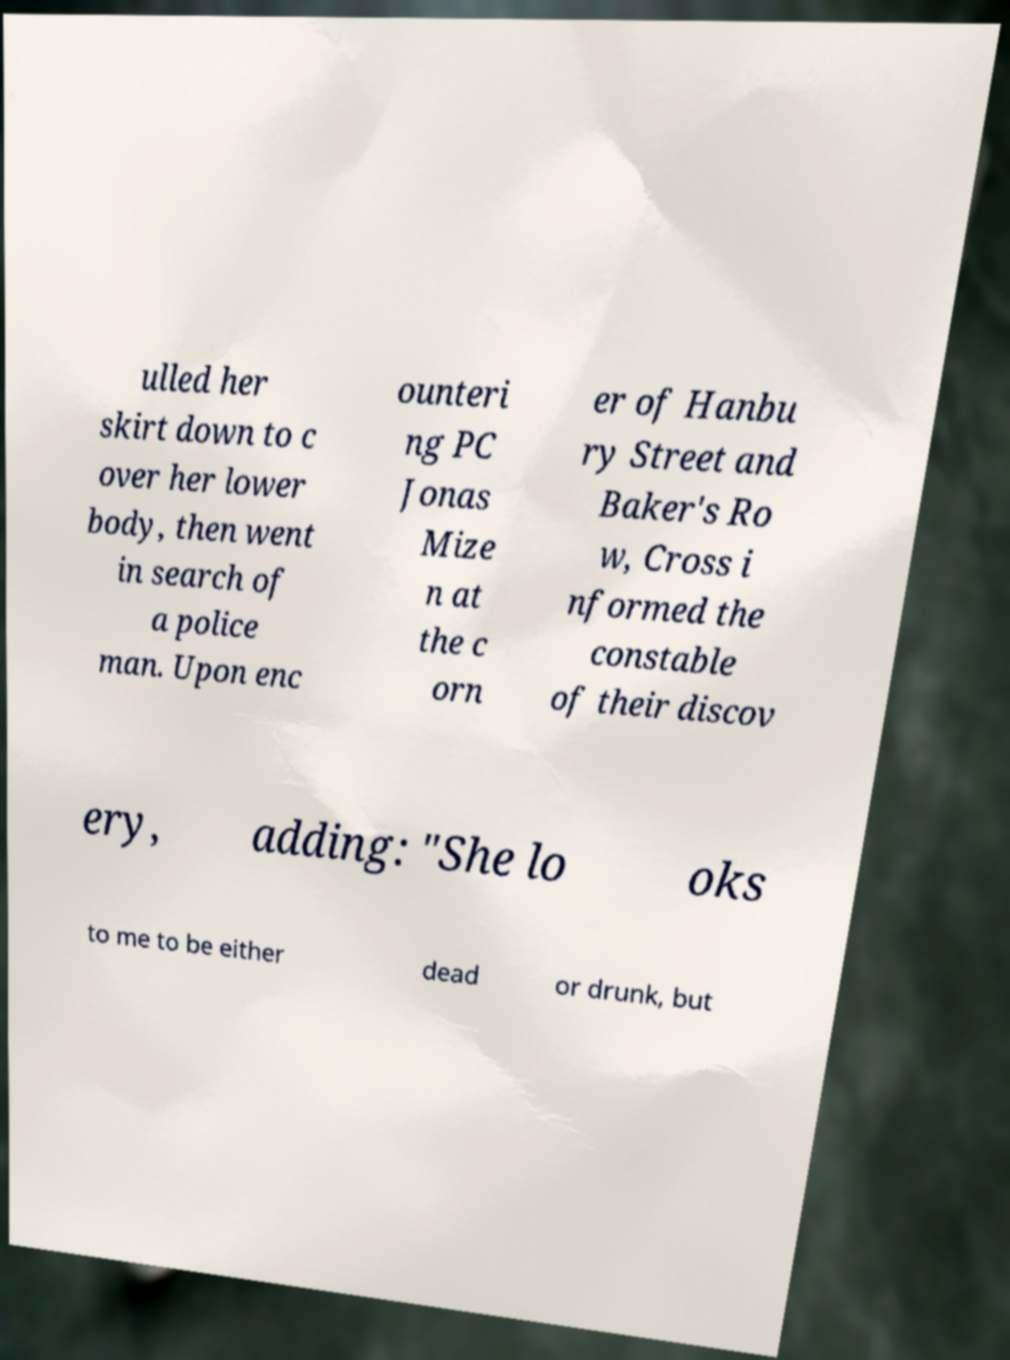What messages or text are displayed in this image? I need them in a readable, typed format. ulled her skirt down to c over her lower body, then went in search of a police man. Upon enc ounteri ng PC Jonas Mize n at the c orn er of Hanbu ry Street and Baker's Ro w, Cross i nformed the constable of their discov ery, adding: "She lo oks to me to be either dead or drunk, but 